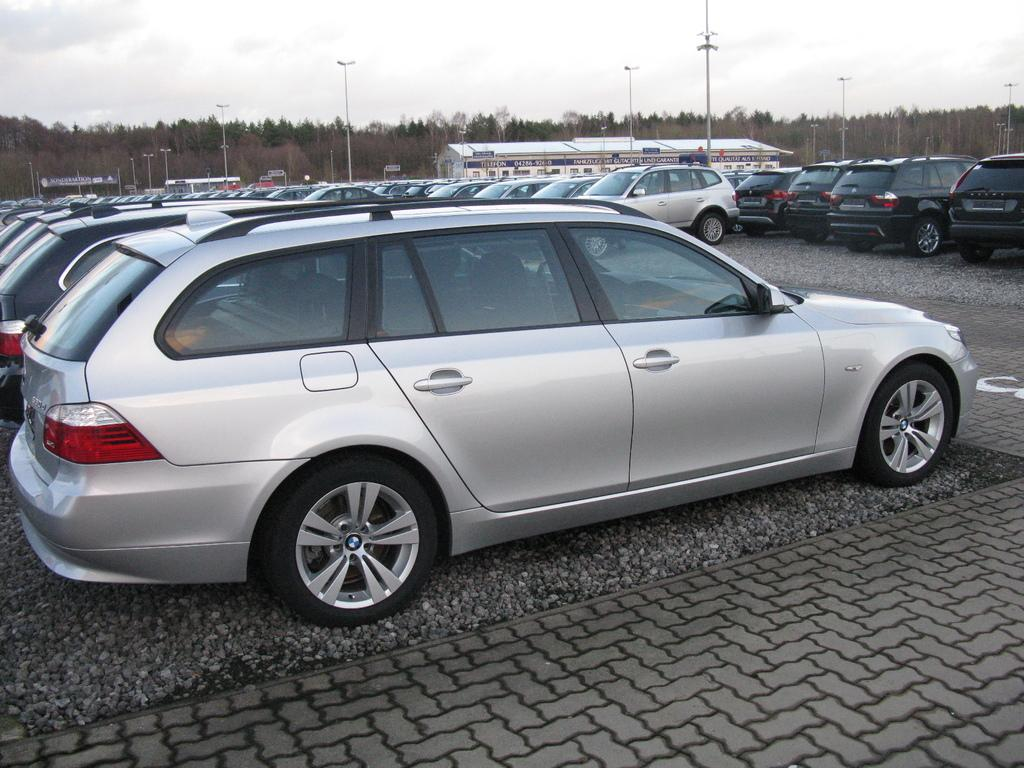What types of objects can be seen in the image? There are vehicles, poles, trees, a house, and boards visible in the image. What is the ground like in the image? The ground is visible in the image, with some stones and objects. What can be seen in the sky in the image? The sky is visible in the image. What type of veil can be seen covering the house in the image? There is no veil present in the image; the house is not covered by any fabric or material. How many masses are being held in the image? There is no indication of any religious gatherings or masses in the image. 